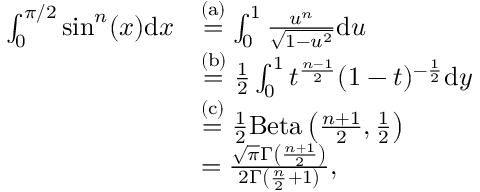<formula> <loc_0><loc_0><loc_500><loc_500>\begin{array} { r l } { \int _ { 0 } ^ { \pi / 2 } \sin ^ { n } ( x ) d x } & { \stackrel { ( a ) } = \int _ { 0 } ^ { 1 } \frac { u ^ { n } } { \sqrt { 1 - u ^ { 2 } } } d u } \\ & { \stackrel { ( b ) } = \frac { 1 } { 2 } \int _ { 0 } ^ { 1 } t ^ { \frac { n - 1 } { 2 } } ( 1 - t ) ^ { - \frac { 1 } { 2 } } d y } \\ & { \stackrel { ( c ) } = \frac { 1 } { 2 } B e t a \left ( \frac { n + 1 } { 2 } , \frac { 1 } { 2 } \right ) } \\ & { = \frac { \sqrt { \pi } \Gamma \left ( \frac { n + 1 } { 2 } \right ) } { 2 \Gamma \left ( \frac { n } { 2 } + 1 \right ) } , } \end{array}</formula> 